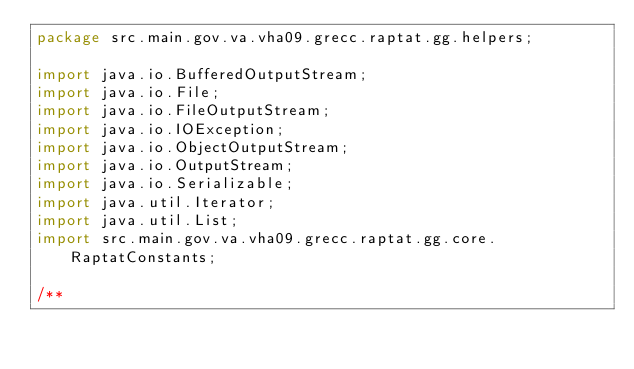Convert code to text. <code><loc_0><loc_0><loc_500><loc_500><_Java_>package src.main.gov.va.vha09.grecc.raptat.gg.helpers;

import java.io.BufferedOutputStream;
import java.io.File;
import java.io.FileOutputStream;
import java.io.IOException;
import java.io.ObjectOutputStream;
import java.io.OutputStream;
import java.io.Serializable;
import java.util.Iterator;
import java.util.List;
import src.main.gov.va.vha09.grecc.raptat.gg.core.RaptatConstants;

/**</code> 